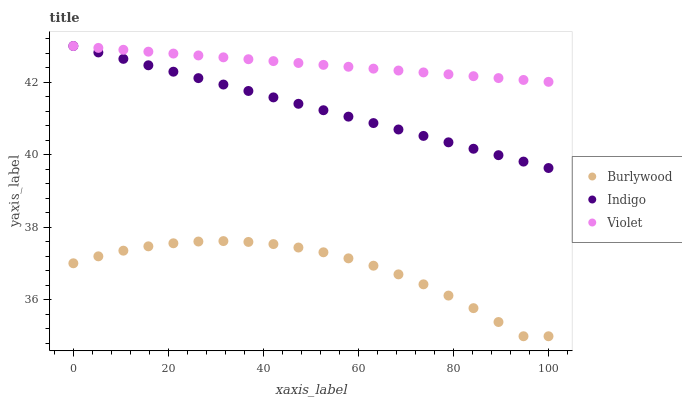Does Burlywood have the minimum area under the curve?
Answer yes or no. Yes. Does Violet have the maximum area under the curve?
Answer yes or no. Yes. Does Indigo have the minimum area under the curve?
Answer yes or no. No. Does Indigo have the maximum area under the curve?
Answer yes or no. No. Is Violet the smoothest?
Answer yes or no. Yes. Is Burlywood the roughest?
Answer yes or no. Yes. Is Indigo the smoothest?
Answer yes or no. No. Is Indigo the roughest?
Answer yes or no. No. Does Burlywood have the lowest value?
Answer yes or no. Yes. Does Indigo have the lowest value?
Answer yes or no. No. Does Violet have the highest value?
Answer yes or no. Yes. Is Burlywood less than Violet?
Answer yes or no. Yes. Is Violet greater than Burlywood?
Answer yes or no. Yes. Does Violet intersect Indigo?
Answer yes or no. Yes. Is Violet less than Indigo?
Answer yes or no. No. Is Violet greater than Indigo?
Answer yes or no. No. Does Burlywood intersect Violet?
Answer yes or no. No. 